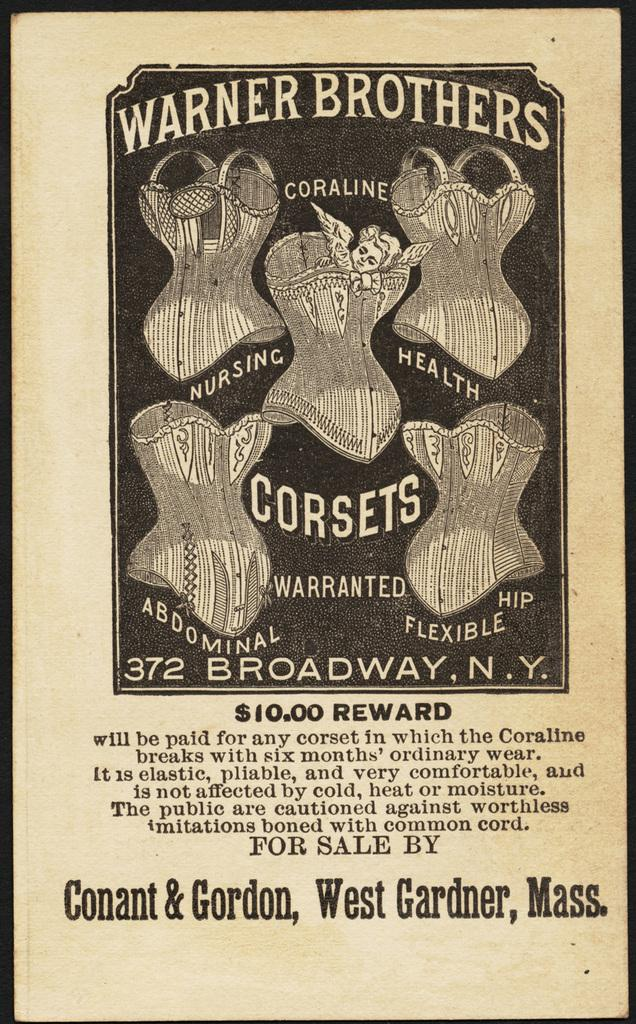What is the main subject in the center of the image? There is a poster in the center of the image. What can be found on the poster? The poster contains objects and text. How is the image framed? There is a black color border around the image. Can you see any sacks near the lake in the image? There is no lake or sacks present in the image; it only contains a poster with objects and text, framed by a black color border. 